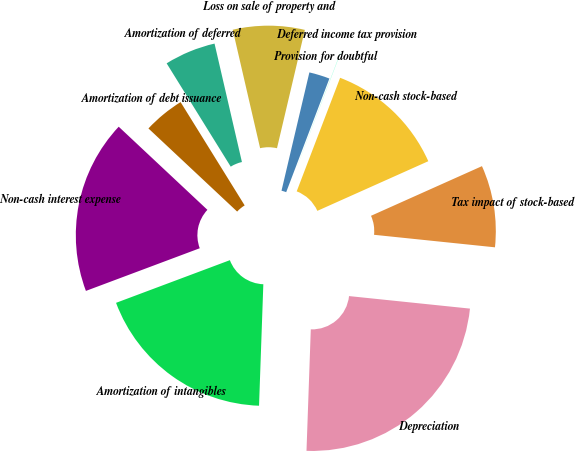<chart> <loc_0><loc_0><loc_500><loc_500><pie_chart><fcel>Depreciation<fcel>Amortization of intangibles<fcel>Non-cash interest expense<fcel>Amortization of debt issuance<fcel>Amortization of deferred<fcel>Loss on sale of property and<fcel>Provision for doubtful<fcel>Deferred income tax provision<fcel>Non-cash stock-based<fcel>Tax impact of stock-based<nl><fcel>23.92%<fcel>18.73%<fcel>17.69%<fcel>4.18%<fcel>5.22%<fcel>7.3%<fcel>2.1%<fcel>0.03%<fcel>12.49%<fcel>8.34%<nl></chart> 